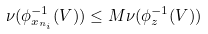Convert formula to latex. <formula><loc_0><loc_0><loc_500><loc_500>\nu ( \phi _ { x _ { n _ { i } } } ^ { - 1 } ( V ) ) \leq M \nu ( \phi _ { z } ^ { - 1 } ( V ) )</formula> 